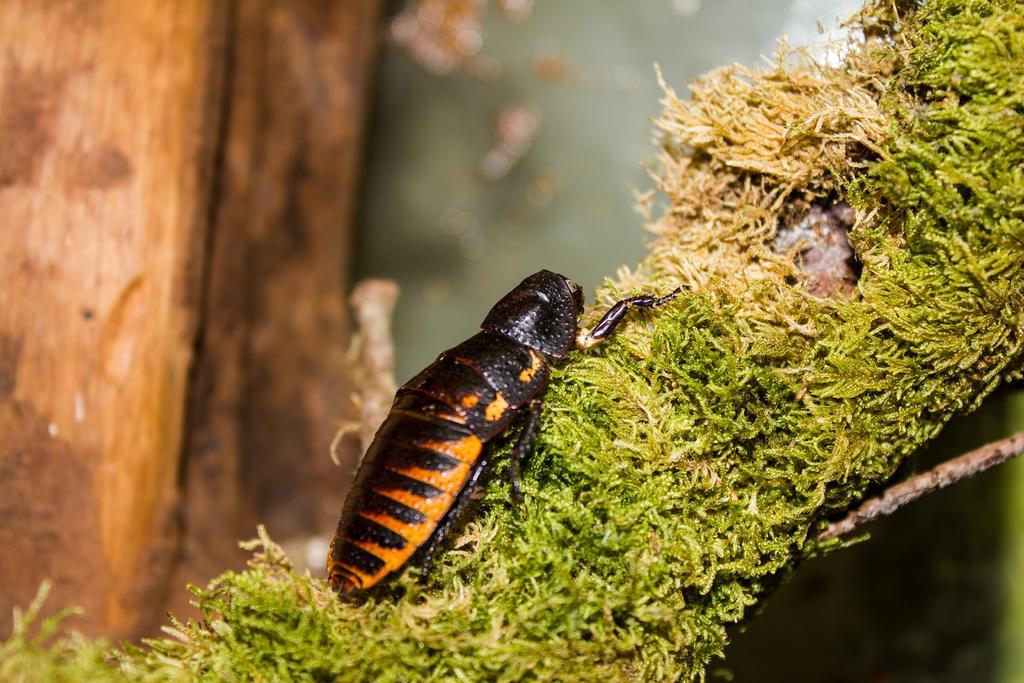Could you give a brief overview of what you see in this image? In this picture we can see an insect on the grass and in the background we can see wooden objects. 